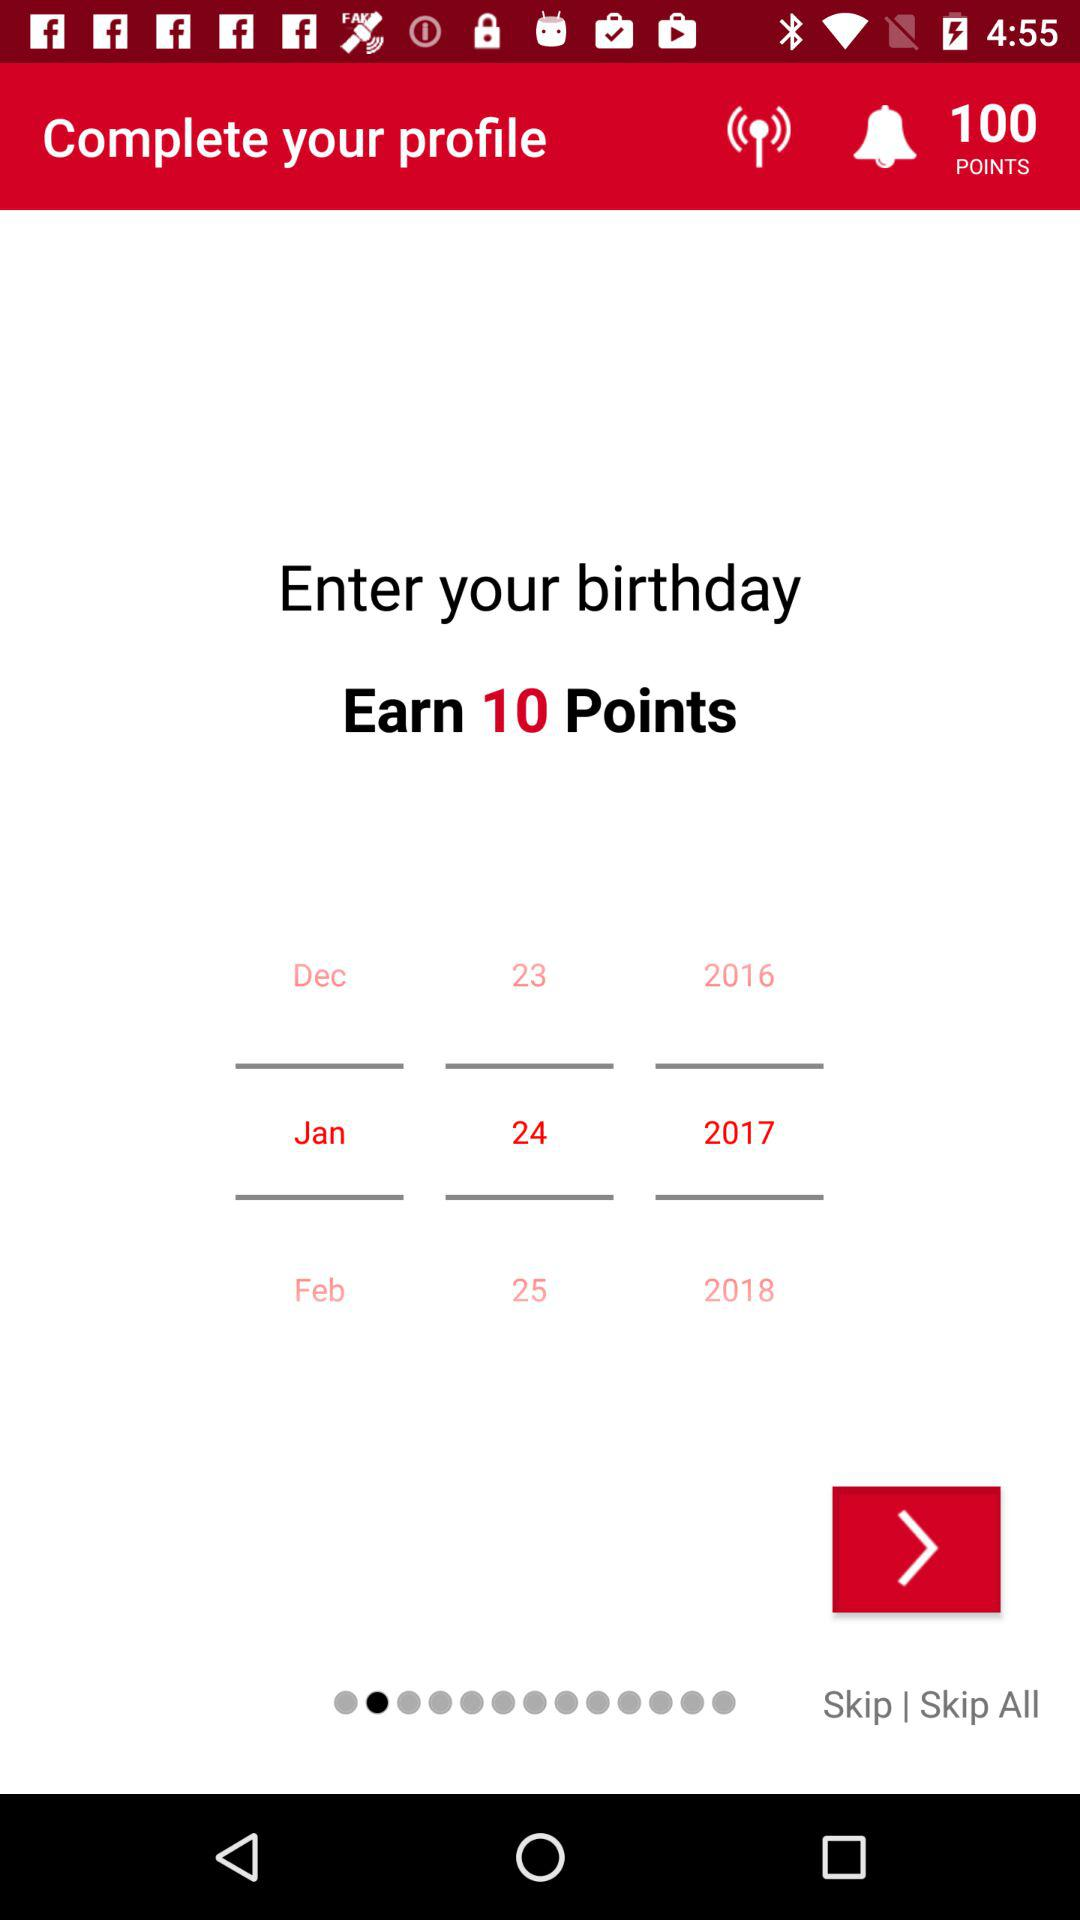What is the selected date? The selected date is January 24, 2017. 